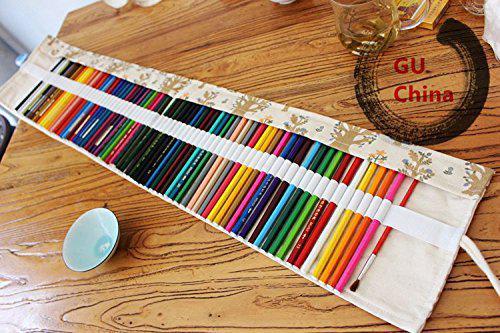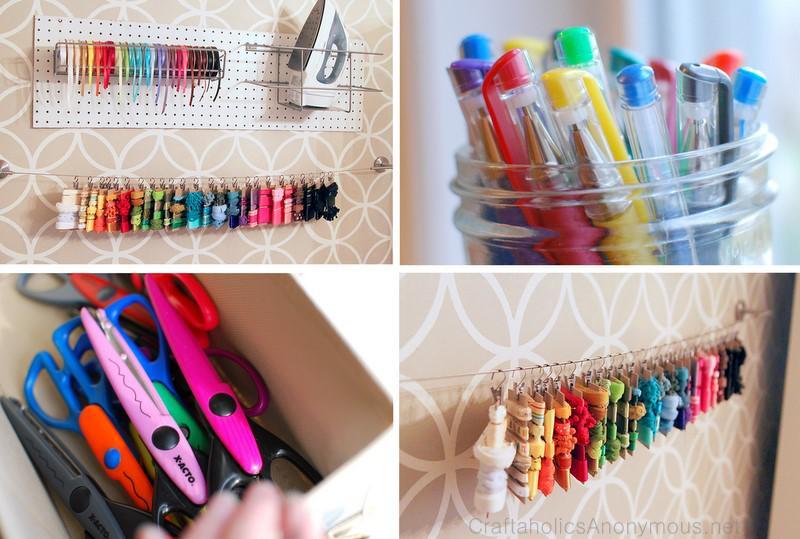The first image is the image on the left, the second image is the image on the right. For the images shown, is this caption "In one image, a red plaid pencil case is unrolled, revealing a long red pocket that contains a collection of pencils, markers, pens, and a green frog eraser." true? Answer yes or no. No. The first image is the image on the left, the second image is the image on the right. Considering the images on both sides, is "One image shows an unrolled pencil case with a solid red and tartan plaid interior, and the other shows a case with a small printed pattern on its interior." valid? Answer yes or no. No. 